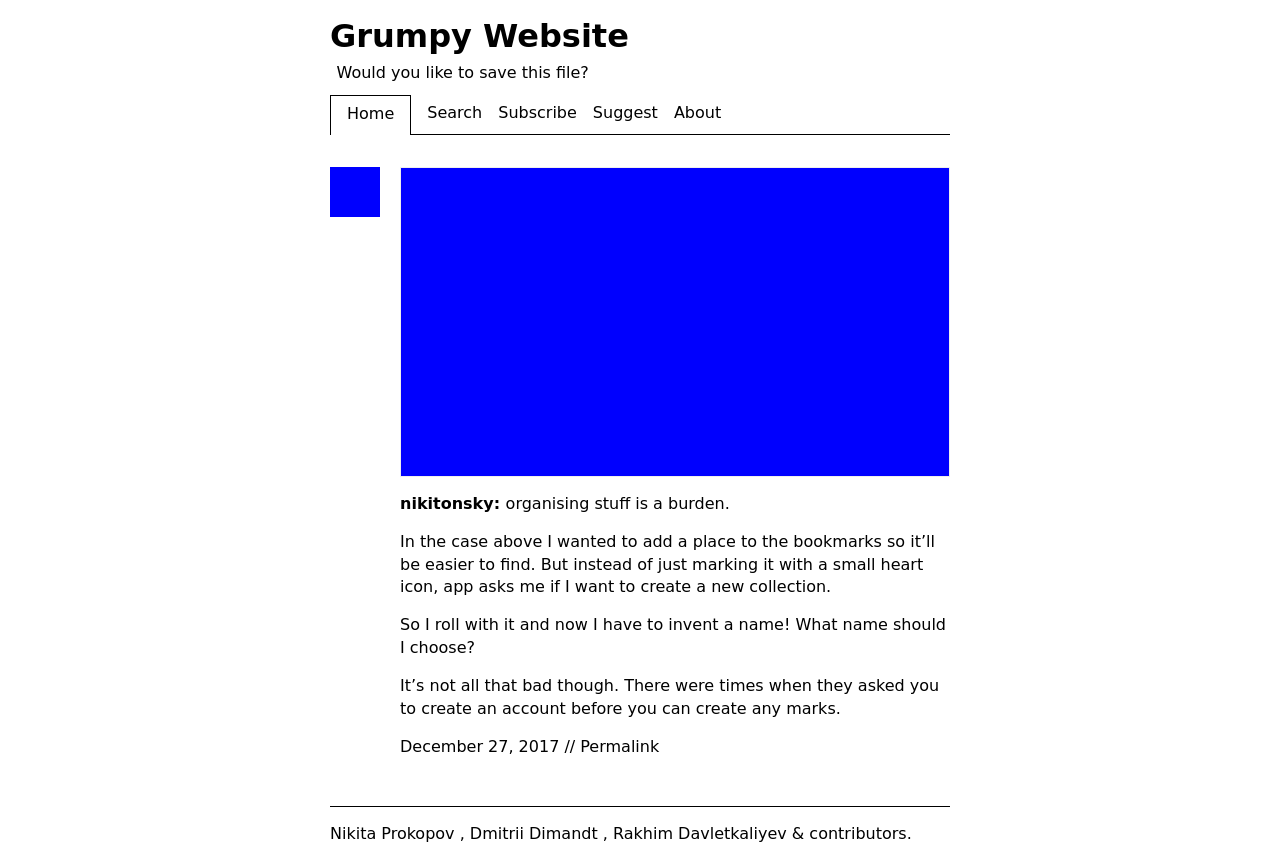Could you detail the process for assembling this website using HTML? To create a website like the one depicted, you would start by writing the HTML structure, essentially setting up the skeleton of the site. This includes defining the DOCTYPE, HTML, head, and body tags. In the head section, you would include metadata like character set and viewport settings, and link external CSS for styling. In the body, you use elements like headers, paragraphs, images, and navigation links. Each piece is styled and positioned using CSS, and you might include JavaScript for interactivity. For instance, the header could have a navigation menu that links to different sections, a main content area displays blog posts or images, and a footer includes copyright and contributor information. 